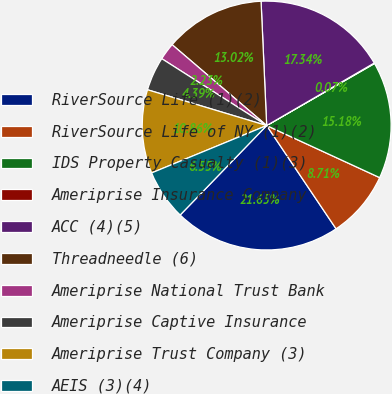Convert chart to OTSL. <chart><loc_0><loc_0><loc_500><loc_500><pie_chart><fcel>RiverSource Life (1)(2)<fcel>RiverSource Life of NY (1)(2)<fcel>IDS Property Casualty (1)(3)<fcel>Ameriprise Insurance Company<fcel>ACC (4)(5)<fcel>Threadneedle (6)<fcel>Ameriprise National Trust Bank<fcel>Ameriprise Captive Insurance<fcel>Ameriprise Trust Company (3)<fcel>AEIS (3)(4)<nl><fcel>21.65%<fcel>8.71%<fcel>15.18%<fcel>0.07%<fcel>17.34%<fcel>13.02%<fcel>2.23%<fcel>4.39%<fcel>10.86%<fcel>6.55%<nl></chart> 